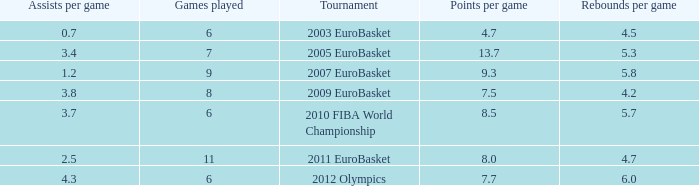How many points per game have the tournament 2005 eurobasket? 13.7. Could you parse the entire table as a dict? {'header': ['Assists per game', 'Games played', 'Tournament', 'Points per game', 'Rebounds per game'], 'rows': [['0.7', '6', '2003 EuroBasket', '4.7', '4.5'], ['3.4', '7', '2005 EuroBasket', '13.7', '5.3'], ['1.2', '9', '2007 EuroBasket', '9.3', '5.8'], ['3.8', '8', '2009 EuroBasket', '7.5', '4.2'], ['3.7', '6', '2010 FIBA World Championship', '8.5', '5.7'], ['2.5', '11', '2011 EuroBasket', '8.0', '4.7'], ['4.3', '6', '2012 Olympics', '7.7', '6.0']]} 